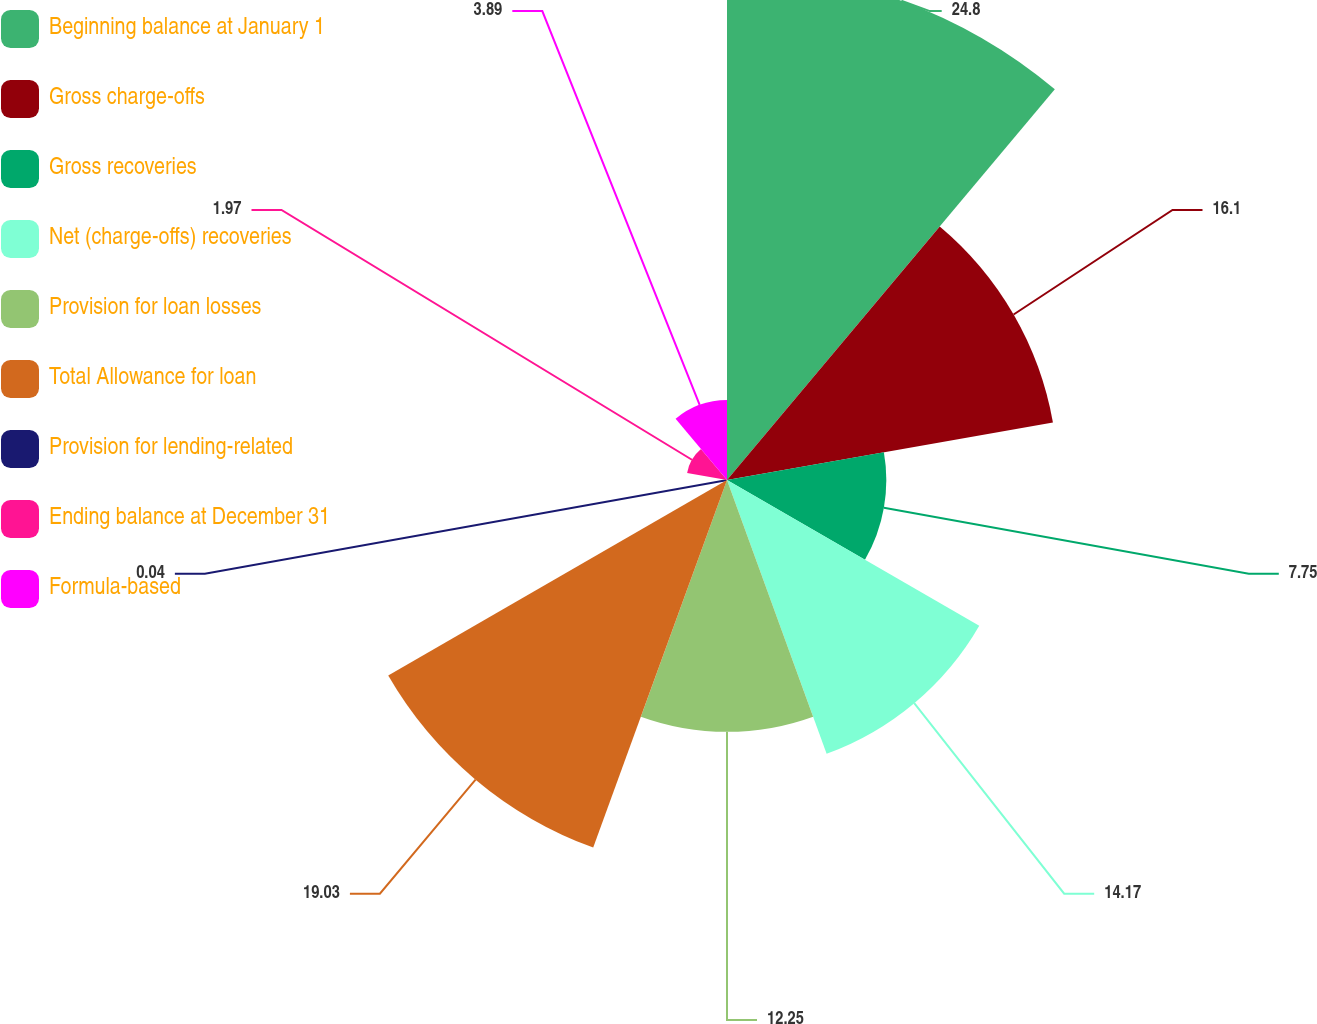Convert chart. <chart><loc_0><loc_0><loc_500><loc_500><pie_chart><fcel>Beginning balance at January 1<fcel>Gross charge-offs<fcel>Gross recoveries<fcel>Net (charge-offs) recoveries<fcel>Provision for loan losses<fcel>Total Allowance for loan<fcel>Provision for lending-related<fcel>Ending balance at December 31<fcel>Formula-based<nl><fcel>24.81%<fcel>16.1%<fcel>7.75%<fcel>14.17%<fcel>12.25%<fcel>19.03%<fcel>0.04%<fcel>1.97%<fcel>3.89%<nl></chart> 